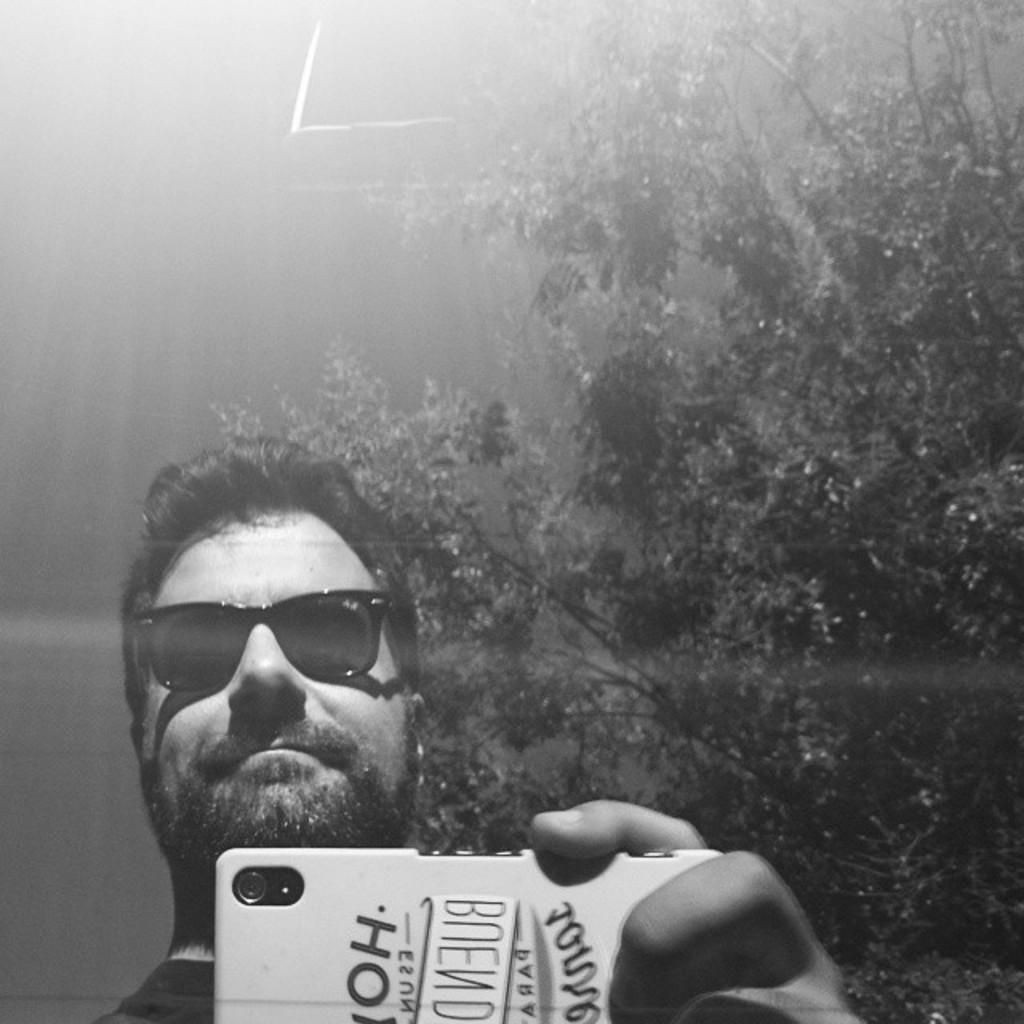What is the color scheme of the image? The image is black and white. Who is present in the image? There is a man in the image. What is the man holding in his hands? The man is holding a mobile in his hands. What accessory is the man wearing? The man is wearing glasses. What can be seen in the background of the image? There is a tree in the background of the image. What type of box is the man sitting on in the image? There is no box present in the image; the man is standing and holding a mobile. 